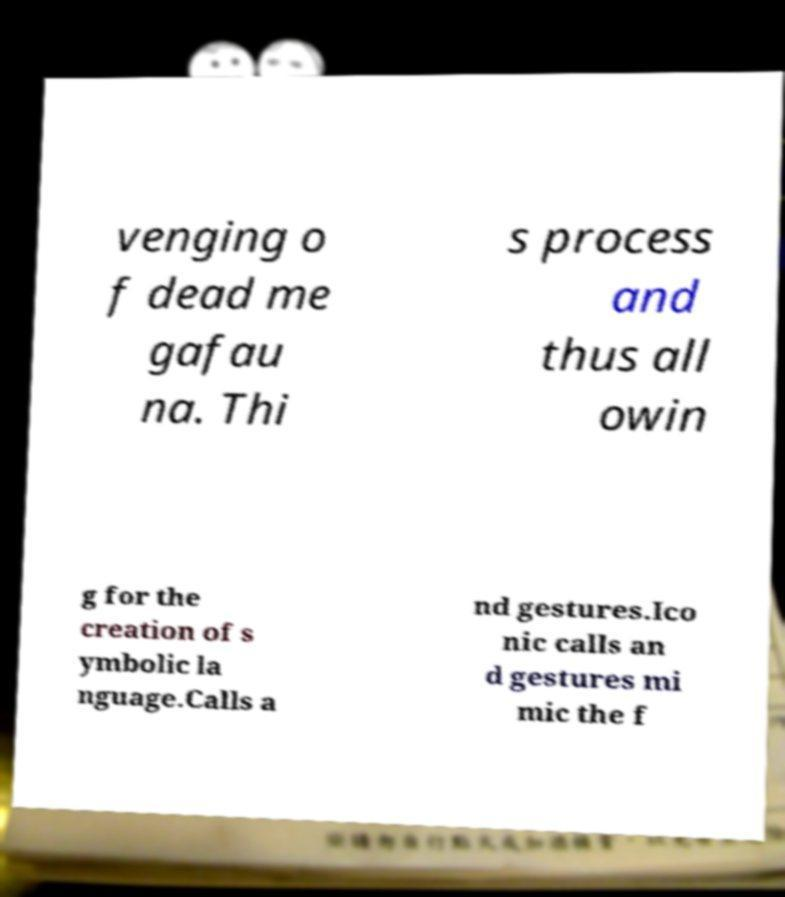Could you assist in decoding the text presented in this image and type it out clearly? venging o f dead me gafau na. Thi s process and thus all owin g for the creation of s ymbolic la nguage.Calls a nd gestures.Ico nic calls an d gestures mi mic the f 